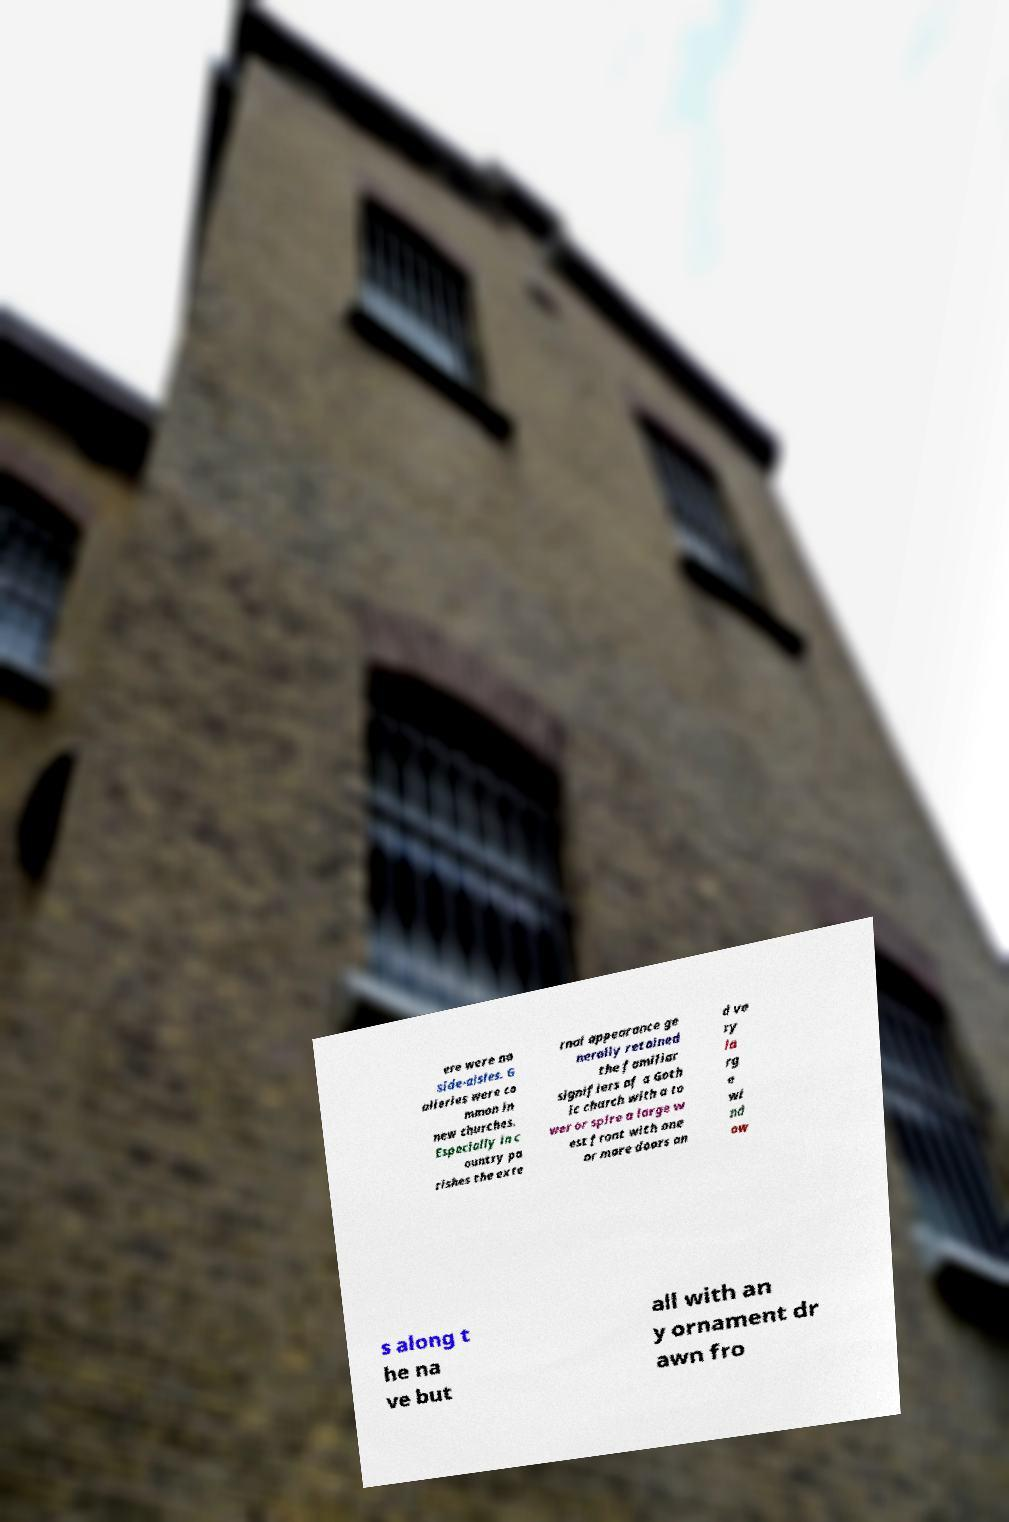Can you read and provide the text displayed in the image?This photo seems to have some interesting text. Can you extract and type it out for me? ere were no side-aisles. G alleries were co mmon in new churches. Especially in c ountry pa rishes the exte rnal appearance ge nerally retained the familiar signifiers of a Goth ic church with a to wer or spire a large w est front with one or more doors an d ve ry la rg e wi nd ow s along t he na ve but all with an y ornament dr awn fro 